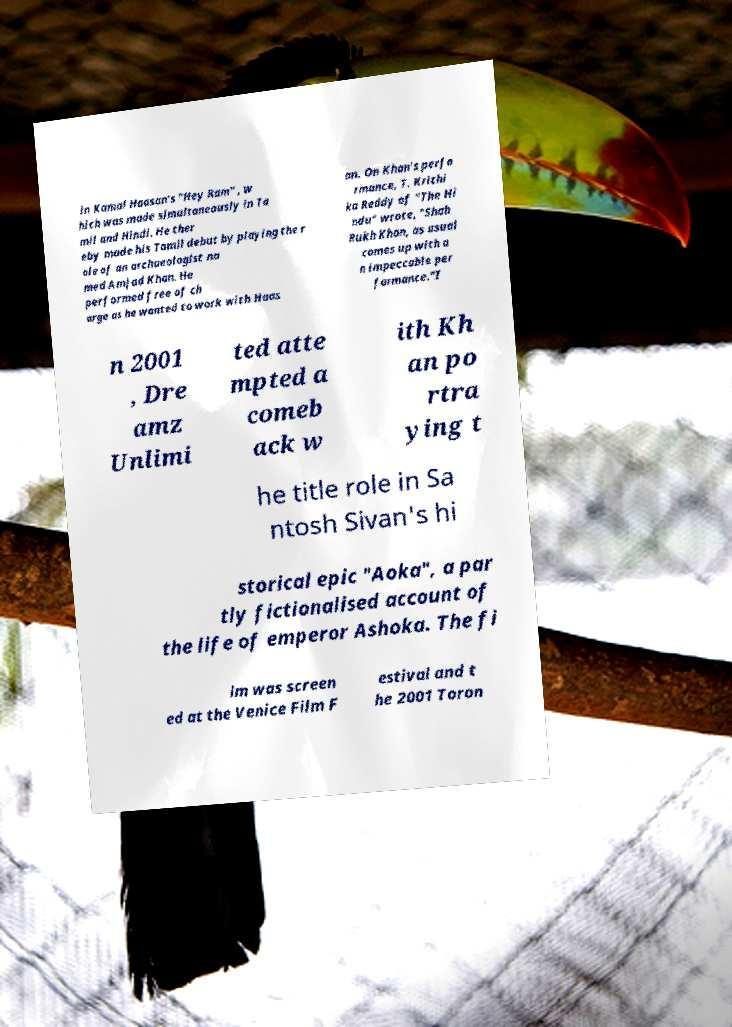Please identify and transcribe the text found in this image. in Kamal Haasan's "Hey Ram" , w hich was made simultaneously in Ta mil and Hindi. He ther eby made his Tamil debut by playing the r ole of an archaeologist na med Amjad Khan. He performed free of ch arge as he wanted to work with Haas an. On Khan's perfo rmance, T. Krithi ka Reddy of "The Hi ndu" wrote, "Shah Rukh Khan, as usual comes up with a n impeccable per formance."I n 2001 , Dre amz Unlimi ted atte mpted a comeb ack w ith Kh an po rtra ying t he title role in Sa ntosh Sivan's hi storical epic "Aoka", a par tly fictionalised account of the life of emperor Ashoka. The fi lm was screen ed at the Venice Film F estival and t he 2001 Toron 